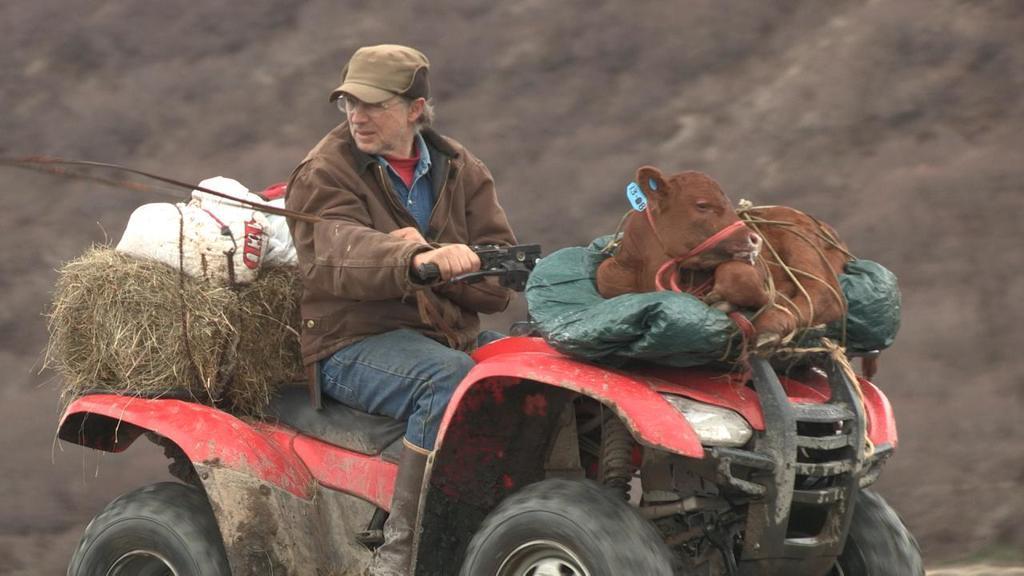Could you give a brief overview of what you see in this image? In this picture we can see a vehicle on the ground with a man, animal, grass and some objects on it. 